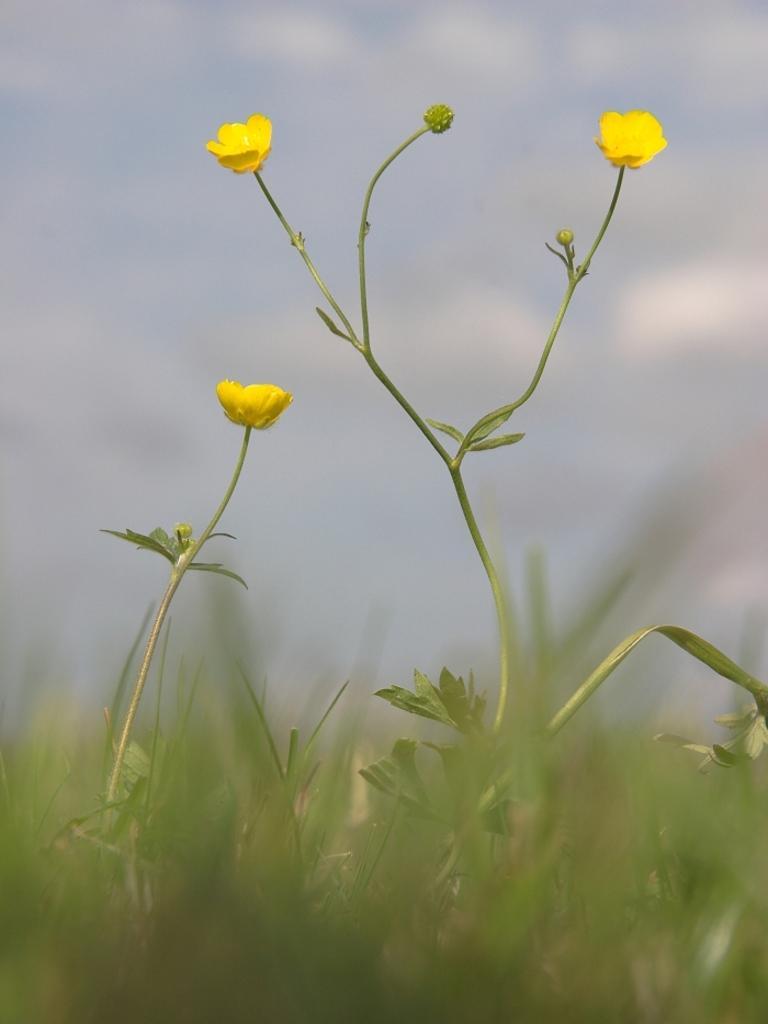How would you summarize this image in a sentence or two? In this image I can see three yellow colour flowers, leaves and grass. In the background I can see clouds and the sky. I can also see this image is little bit blurry. 